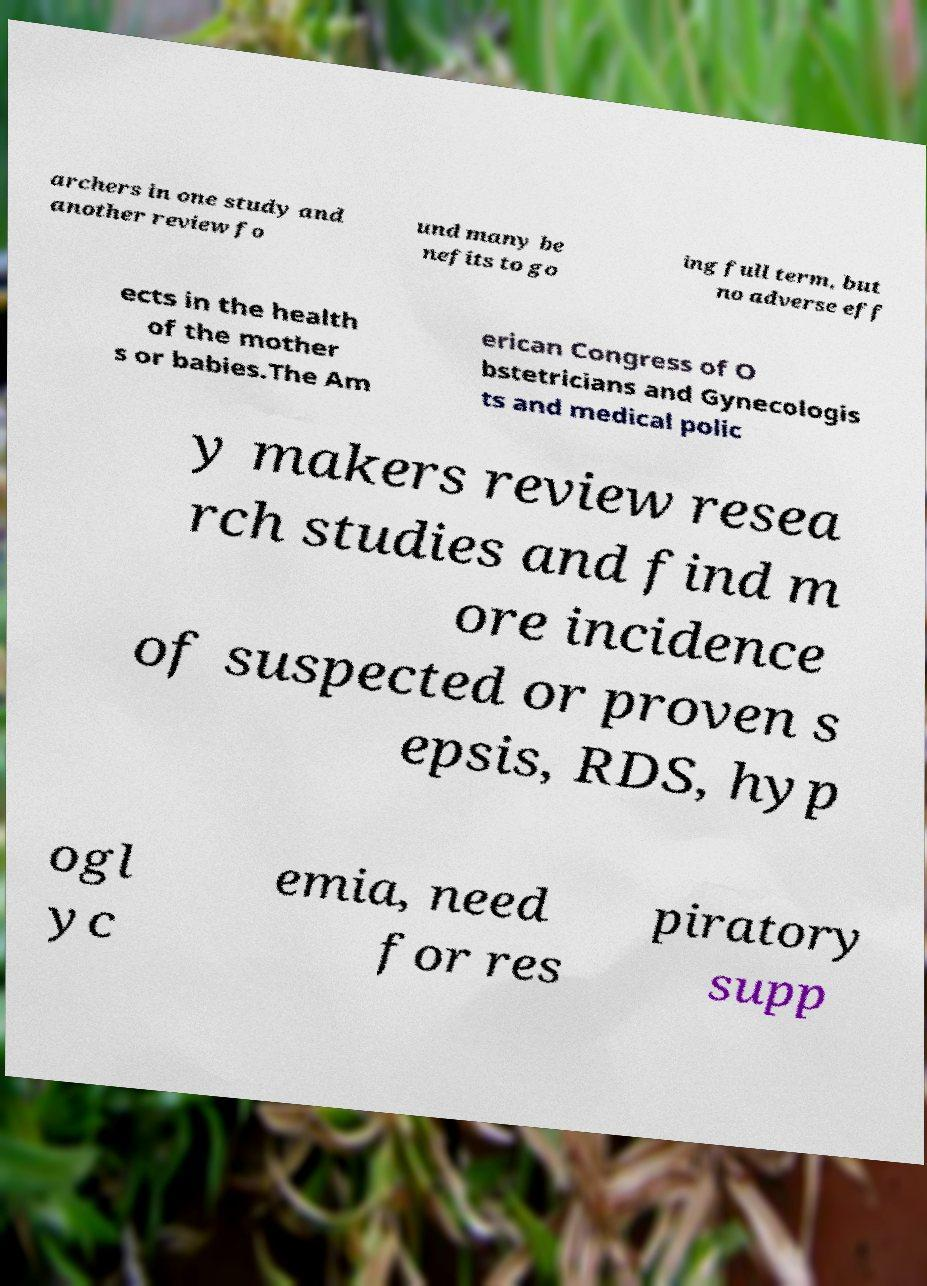There's text embedded in this image that I need extracted. Can you transcribe it verbatim? archers in one study and another review fo und many be nefits to go ing full term, but no adverse eff ects in the health of the mother s or babies.The Am erican Congress of O bstetricians and Gynecologis ts and medical polic y makers review resea rch studies and find m ore incidence of suspected or proven s epsis, RDS, hyp ogl yc emia, need for res piratory supp 